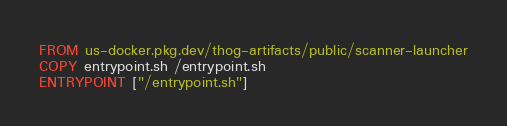Convert code to text. <code><loc_0><loc_0><loc_500><loc_500><_Dockerfile_>FROM us-docker.pkg.dev/thog-artifacts/public/scanner-launcher
COPY entrypoint.sh /entrypoint.sh
ENTRYPOINT ["/entrypoint.sh"]</code> 